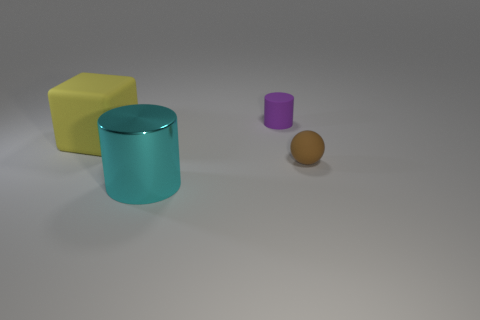What number of brown spheres are the same size as the purple matte object?
Your answer should be compact. 1. There is another object that is the same shape as the cyan object; what material is it?
Offer a terse response. Rubber. What is the color of the big object in front of the small ball?
Make the answer very short. Cyan. Is the number of cyan objects right of the small purple matte thing greater than the number of metal cylinders?
Your response must be concise. No. What color is the matte ball?
Offer a terse response. Brown. The small thing that is in front of the rubber thing to the left of the cylinder that is in front of the small matte ball is what shape?
Offer a very short reply. Sphere. What is the thing that is behind the big metal cylinder and left of the purple matte object made of?
Your answer should be compact. Rubber. What shape is the metallic object that is in front of the cylinder that is on the right side of the cyan shiny cylinder?
Give a very brief answer. Cylinder. Is there any other thing of the same color as the big block?
Make the answer very short. No. Is the size of the metal cylinder the same as the cylinder that is behind the large rubber cube?
Make the answer very short. No. 